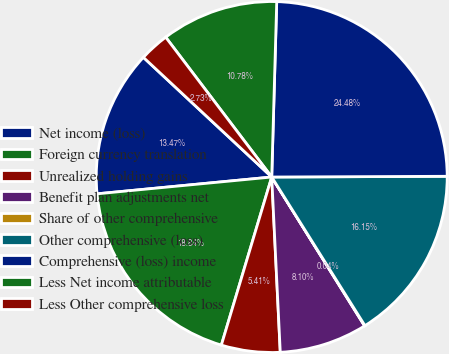<chart> <loc_0><loc_0><loc_500><loc_500><pie_chart><fcel>Net income (loss)<fcel>Foreign currency translation<fcel>Unrealized holding gains<fcel>Benefit plan adjustments net<fcel>Share of other comprehensive<fcel>Other comprehensive (loss)<fcel>Comprehensive (loss) income<fcel>Less Net income attributable<fcel>Less Other comprehensive loss<nl><fcel>13.47%<fcel>18.84%<fcel>5.41%<fcel>8.1%<fcel>0.04%<fcel>16.15%<fcel>24.48%<fcel>10.78%<fcel>2.73%<nl></chart> 